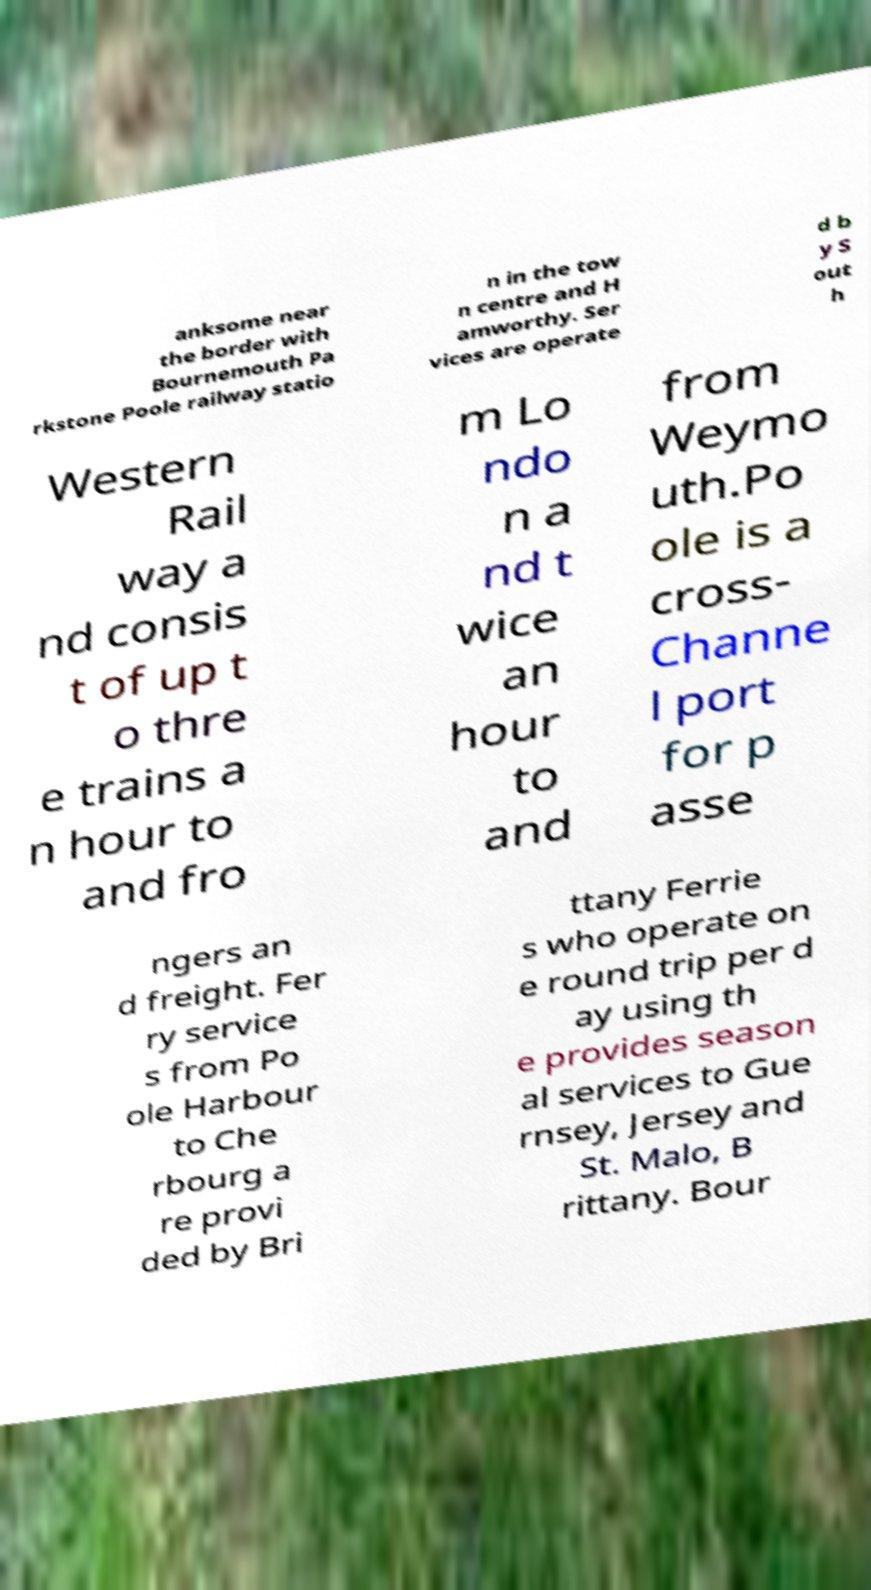What messages or text are displayed in this image? I need them in a readable, typed format. anksome near the border with Bournemouth Pa rkstone Poole railway statio n in the tow n centre and H amworthy. Ser vices are operate d b y S out h Western Rail way a nd consis t of up t o thre e trains a n hour to and fro m Lo ndo n a nd t wice an hour to and from Weymo uth.Po ole is a cross- Channe l port for p asse ngers an d freight. Fer ry service s from Po ole Harbour to Che rbourg a re provi ded by Bri ttany Ferrie s who operate on e round trip per d ay using th e provides season al services to Gue rnsey, Jersey and St. Malo, B rittany. Bour 